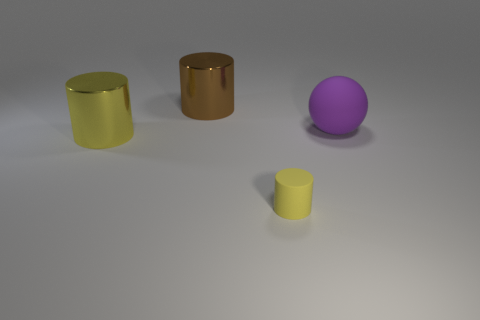Subtract all cyan cubes. How many yellow cylinders are left? 2 Subtract all large yellow cylinders. How many cylinders are left? 2 Add 4 blue metal cylinders. How many objects exist? 8 Subtract 1 cylinders. How many cylinders are left? 2 Subtract all cylinders. How many objects are left? 1 Subtract 1 purple balls. How many objects are left? 3 Subtract all green cylinders. Subtract all yellow balls. How many cylinders are left? 3 Subtract all large blue cylinders. Subtract all large yellow metallic cylinders. How many objects are left? 3 Add 3 purple objects. How many purple objects are left? 4 Add 4 purple spheres. How many purple spheres exist? 5 